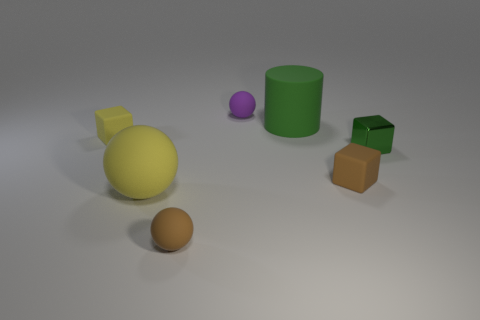The cube that is the same color as the large rubber ball is what size?
Give a very brief answer. Small. What is the shape of the thing that is the same color as the cylinder?
Ensure brevity in your answer.  Cube. What size is the matte thing that is both behind the small shiny cube and on the right side of the tiny purple matte object?
Keep it short and to the point. Large. Is the color of the big ball on the left side of the small green metallic block the same as the rubber block that is left of the small brown sphere?
Give a very brief answer. Yes. How many other objects are the same material as the purple thing?
Ensure brevity in your answer.  5. There is a small thing that is both on the right side of the small purple thing and to the left of the green metal thing; what shape is it?
Provide a succinct answer. Cube. There is a cylinder; is its color the same as the metal object right of the large rubber cylinder?
Offer a very short reply. Yes. Does the green thing that is in front of the green cylinder have the same size as the purple matte ball?
Ensure brevity in your answer.  Yes. What material is the yellow thing that is the same shape as the small purple matte thing?
Ensure brevity in your answer.  Rubber. Does the large yellow matte thing have the same shape as the purple object?
Your answer should be very brief. Yes. 